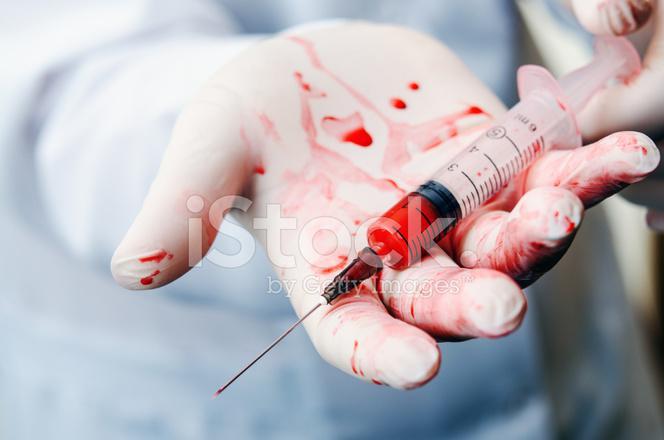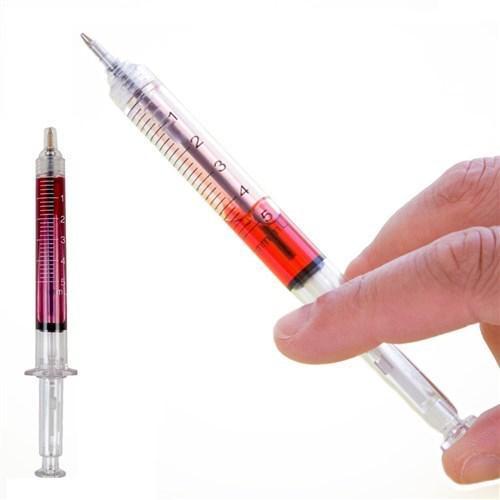The first image is the image on the left, the second image is the image on the right. Assess this claim about the two images: "A gloved hand holds an uncapped syringe in one image.". Correct or not? Answer yes or no. Yes. The first image is the image on the left, the second image is the image on the right. Considering the images on both sides, is "There are needles with red liquid and two hands." valid? Answer yes or no. Yes. 